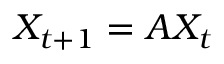Convert formula to latex. <formula><loc_0><loc_0><loc_500><loc_500>X _ { t + 1 } = A X _ { t }</formula> 